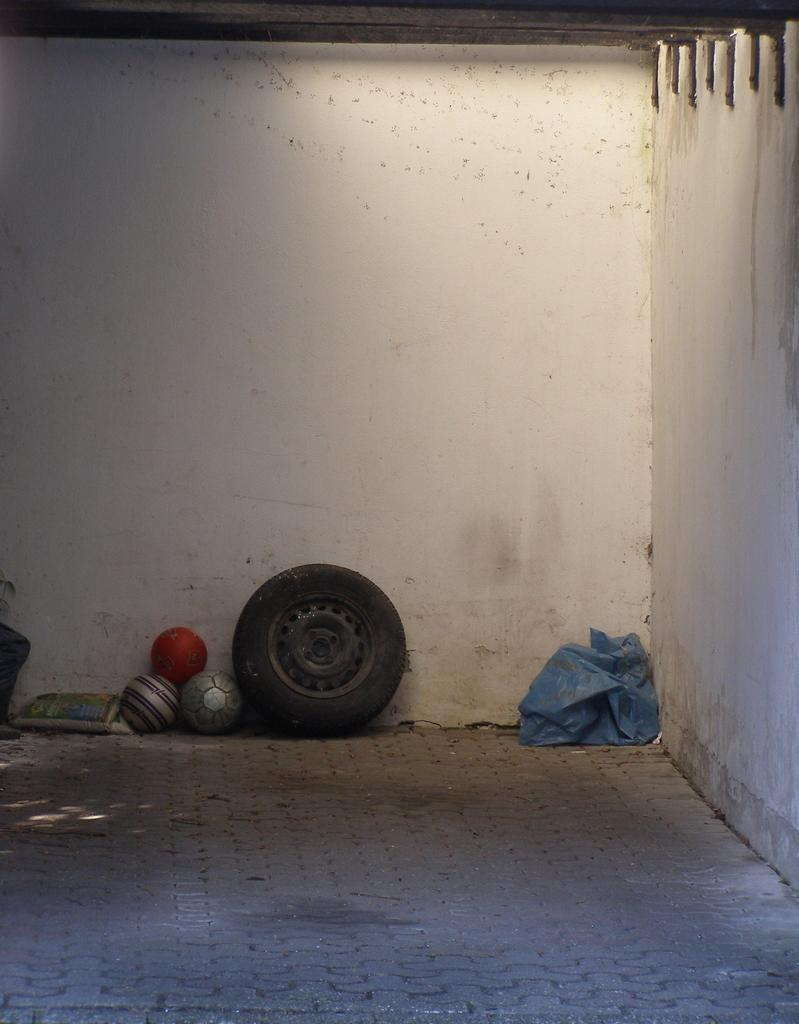What type of objects can be seen in the image? There are balls in the image. Can you describe the structure in the image? There is a tier in the image. What is the color and material of the cover in the image? There is a blue color plastic cover in the image. What is on the floor in the image? There are objects on the floor in the image. What can be seen in the background of the image? There is a wall visible in the image. What type of advice does the queen give to the carpenter in the image? There is no queen or carpenter present in the image, so no such interaction can be observed. Can you tell me how many owls are sitting on the balls in the image? There are no owls present in the image; only balls, a tier, a blue color plastic cover, objects on the floor, and a wall are visible. 